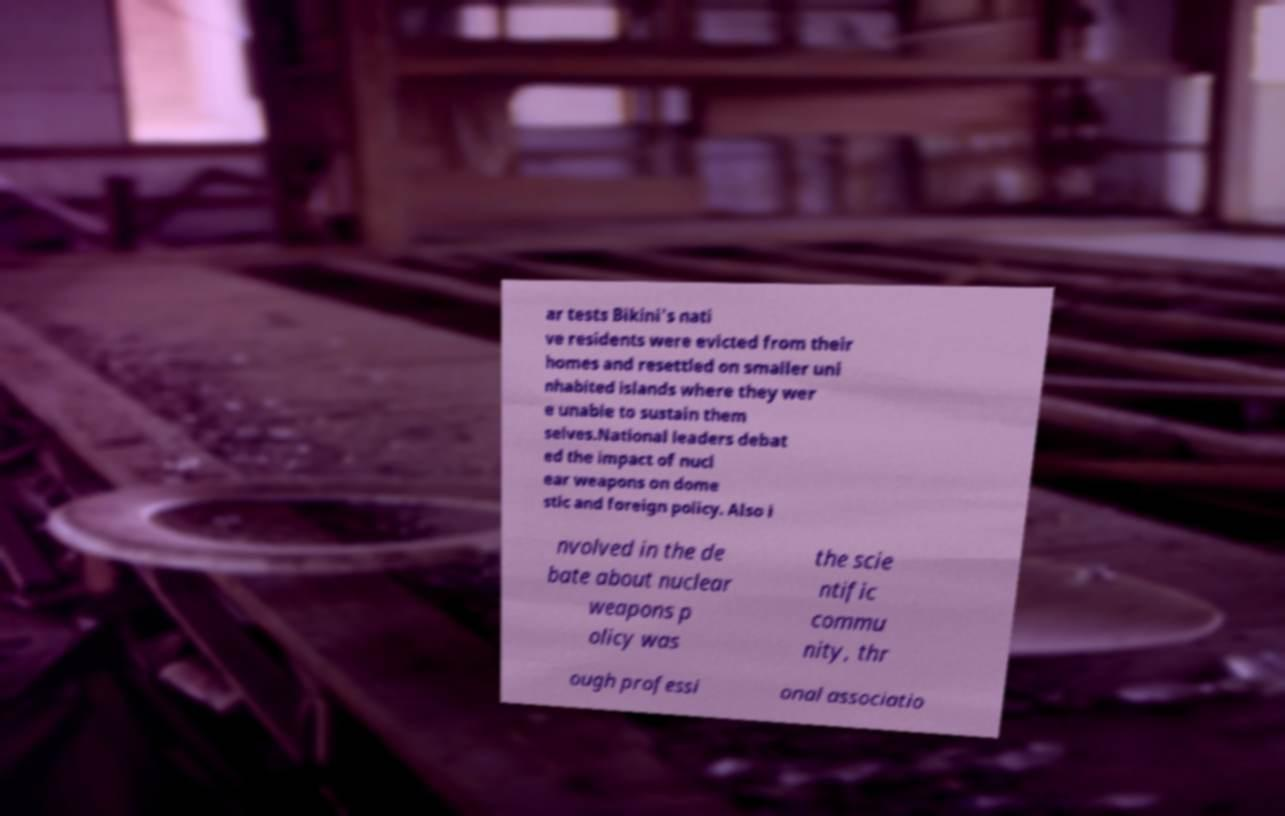For documentation purposes, I need the text within this image transcribed. Could you provide that? ar tests Bikini's nati ve residents were evicted from their homes and resettled on smaller uni nhabited islands where they wer e unable to sustain them selves.National leaders debat ed the impact of nucl ear weapons on dome stic and foreign policy. Also i nvolved in the de bate about nuclear weapons p olicy was the scie ntific commu nity, thr ough professi onal associatio 